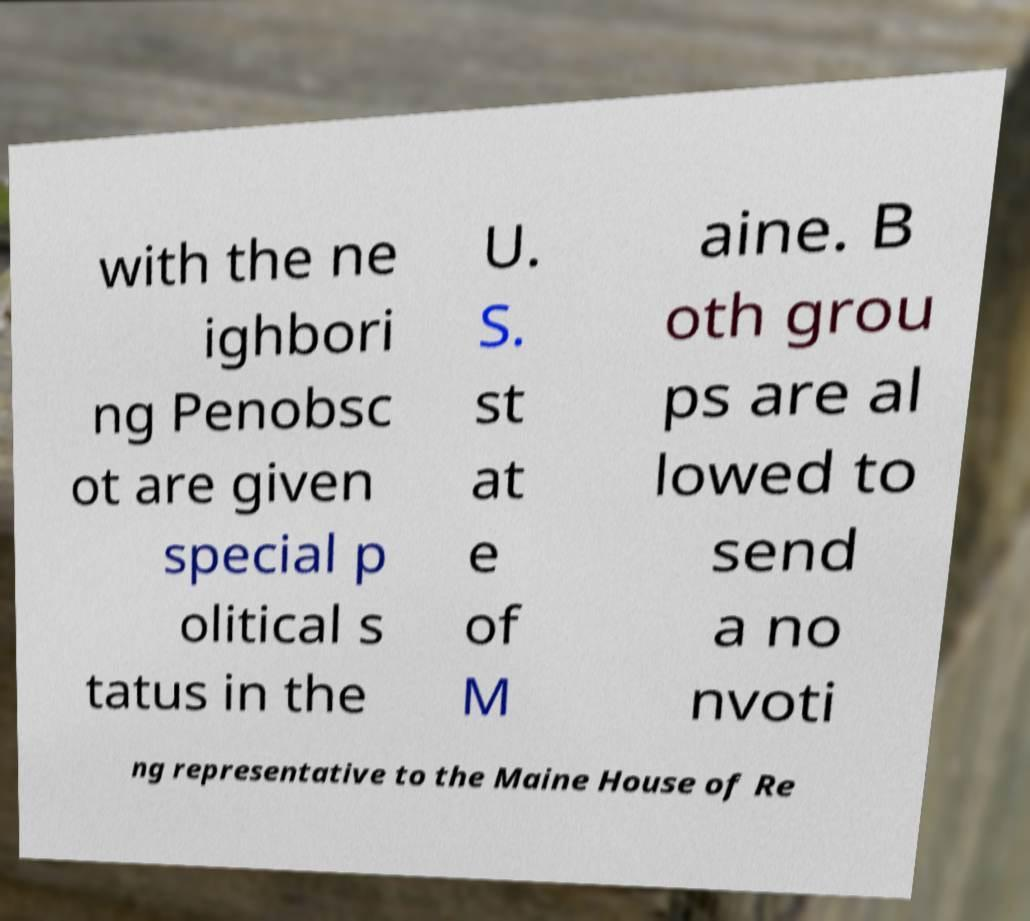For documentation purposes, I need the text within this image transcribed. Could you provide that? with the ne ighbori ng Penobsc ot are given special p olitical s tatus in the U. S. st at e of M aine. B oth grou ps are al lowed to send a no nvoti ng representative to the Maine House of Re 